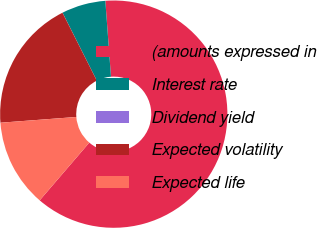Convert chart. <chart><loc_0><loc_0><loc_500><loc_500><pie_chart><fcel>(amounts expressed in<fcel>Interest rate<fcel>Dividend yield<fcel>Expected volatility<fcel>Expected life<nl><fcel>62.47%<fcel>6.26%<fcel>0.01%<fcel>18.75%<fcel>12.5%<nl></chart> 